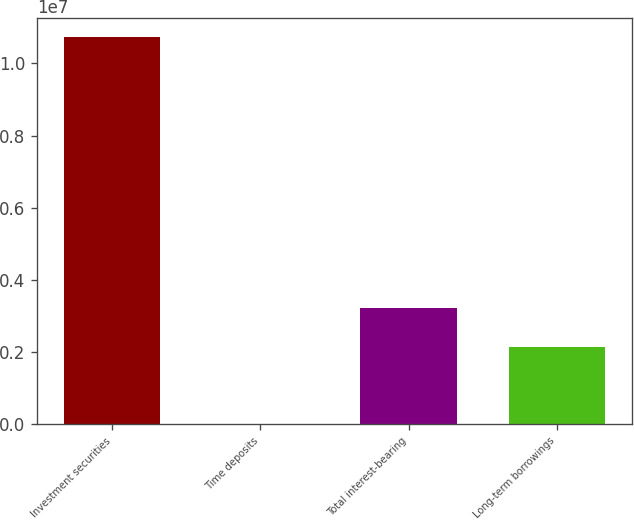Convert chart to OTSL. <chart><loc_0><loc_0><loc_500><loc_500><bar_chart><fcel>Investment securities<fcel>Time deposits<fcel>Total interest-bearing<fcel>Long-term borrowings<nl><fcel>1.07231e+07<fcel>9408<fcel>3.22351e+06<fcel>2.15214e+06<nl></chart> 